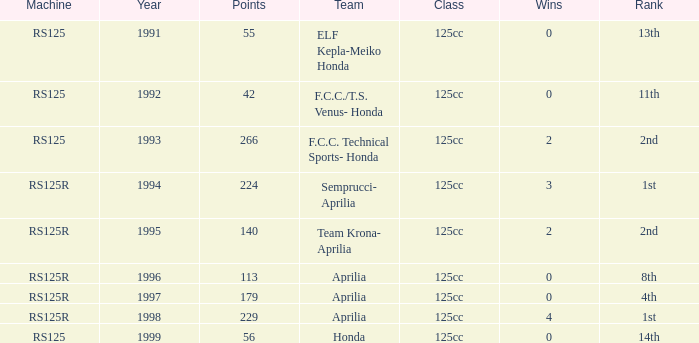Which year had a team of Aprilia and a rank of 4th? 1997.0. 